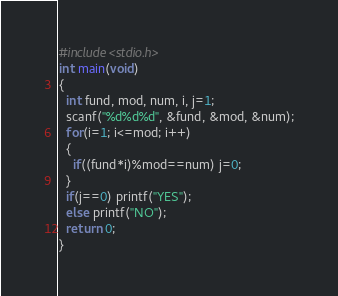<code> <loc_0><loc_0><loc_500><loc_500><_C_>#include<stdio.h>
int main(void)
{
  int fund, mod, num, i, j=1;
  scanf("%d%d%d", &fund, &mod, &num);
  for(i=1; i<=mod; i++)
  {
    if((fund*i)%mod==num) j=0;
  }
  if(j==0) printf("YES");
  else printf("NO");
  return 0;
}</code> 